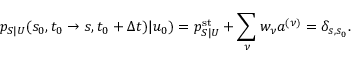<formula> <loc_0><loc_0><loc_500><loc_500>p _ { S | U } ( s _ { 0 } , t _ { 0 } \to s , t _ { 0 } + \Delta t ) | u _ { 0 } ) = p _ { S | U } ^ { s t } + \sum _ { \nu } w _ { \nu } a ^ { ( \nu ) } = \delta _ { s , s _ { 0 } } .</formula> 